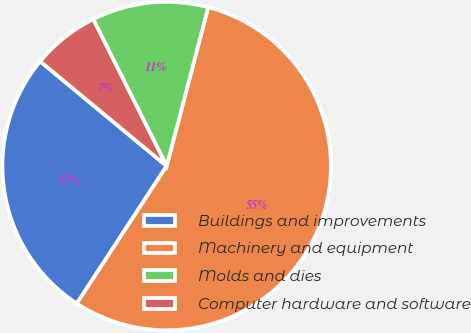Convert chart to OTSL. <chart><loc_0><loc_0><loc_500><loc_500><pie_chart><fcel>Buildings and improvements<fcel>Machinery and equipment<fcel>Molds and dies<fcel>Computer hardware and software<nl><fcel>26.79%<fcel>55.13%<fcel>11.46%<fcel>6.61%<nl></chart> 